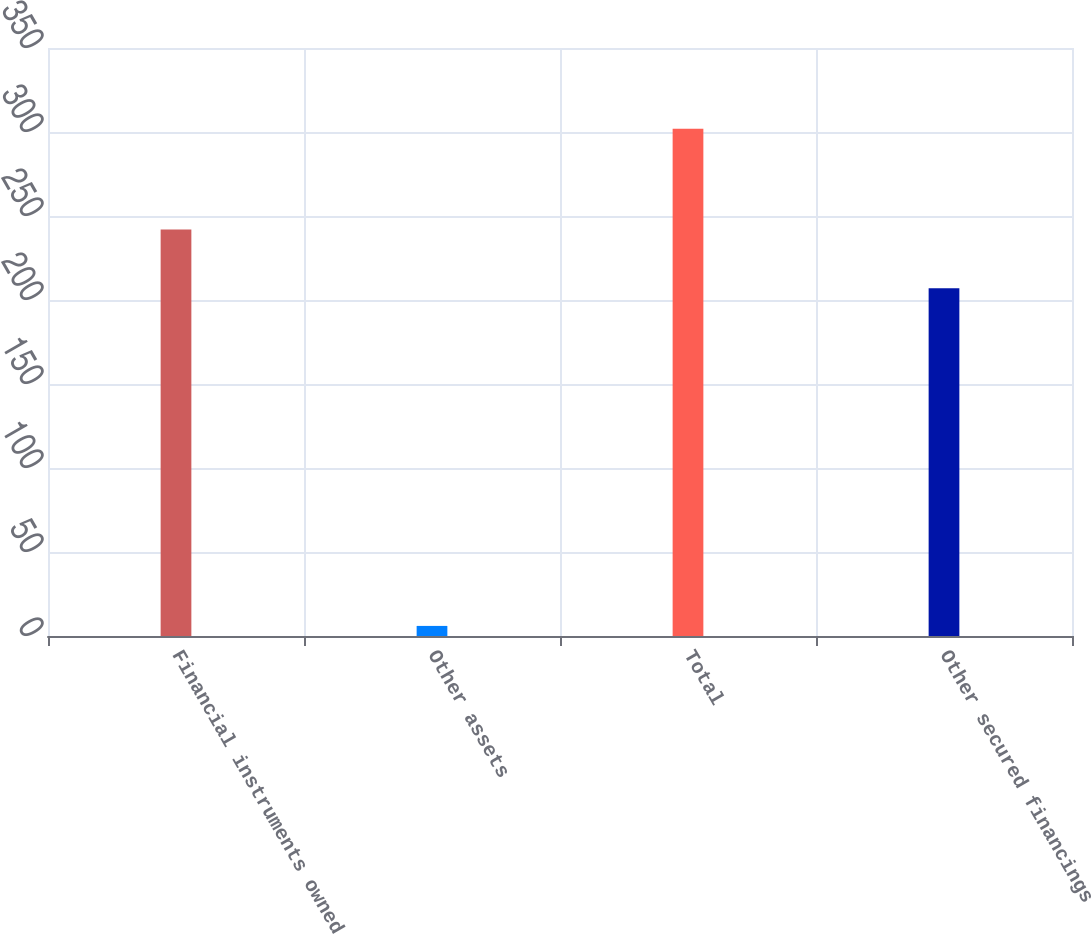<chart> <loc_0><loc_0><loc_500><loc_500><bar_chart><fcel>Financial instruments owned<fcel>Other assets<fcel>Total<fcel>Other secured financings<nl><fcel>242<fcel>6<fcel>302<fcel>207<nl></chart> 